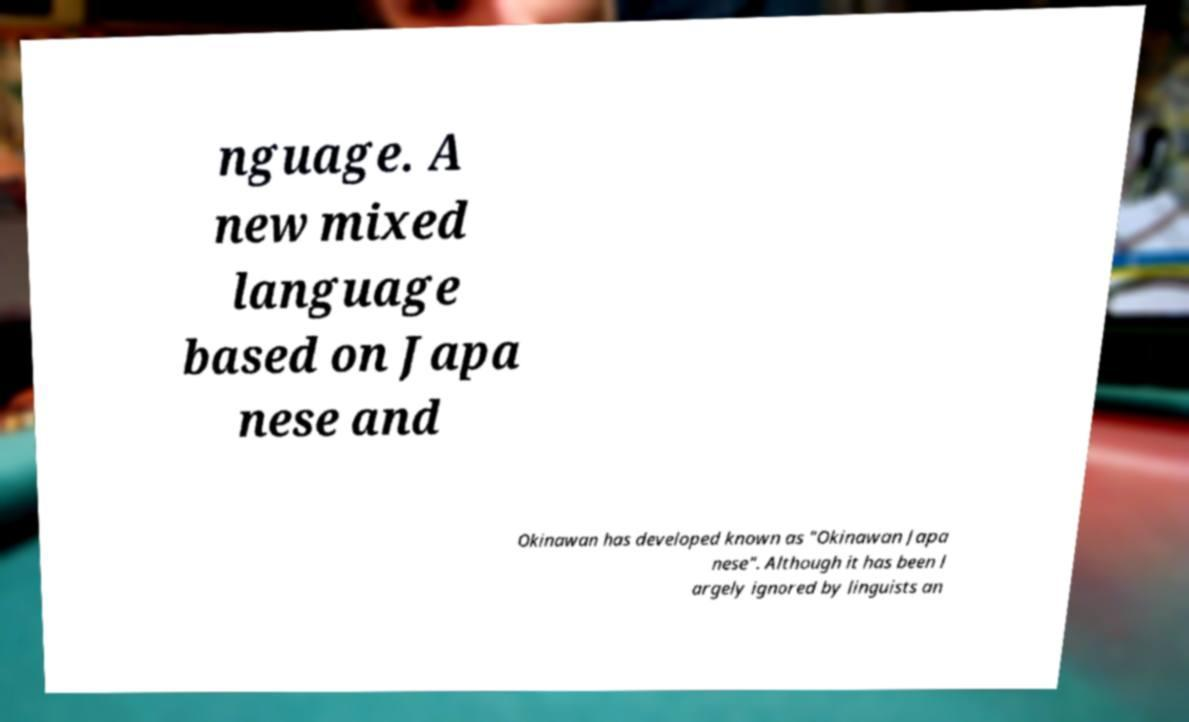There's text embedded in this image that I need extracted. Can you transcribe it verbatim? nguage. A new mixed language based on Japa nese and Okinawan has developed known as "Okinawan Japa nese". Although it has been l argely ignored by linguists an 